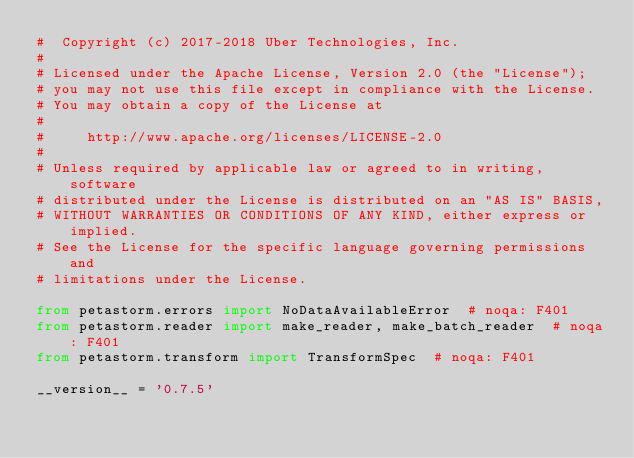<code> <loc_0><loc_0><loc_500><loc_500><_Python_>#  Copyright (c) 2017-2018 Uber Technologies, Inc.
#
# Licensed under the Apache License, Version 2.0 (the "License");
# you may not use this file except in compliance with the License.
# You may obtain a copy of the License at
#
#     http://www.apache.org/licenses/LICENSE-2.0
#
# Unless required by applicable law or agreed to in writing, software
# distributed under the License is distributed on an "AS IS" BASIS,
# WITHOUT WARRANTIES OR CONDITIONS OF ANY KIND, either express or implied.
# See the License for the specific language governing permissions and
# limitations under the License.

from petastorm.errors import NoDataAvailableError  # noqa: F401
from petastorm.reader import make_reader, make_batch_reader  # noqa: F401
from petastorm.transform import TransformSpec  # noqa: F401

__version__ = '0.7.5'
</code> 